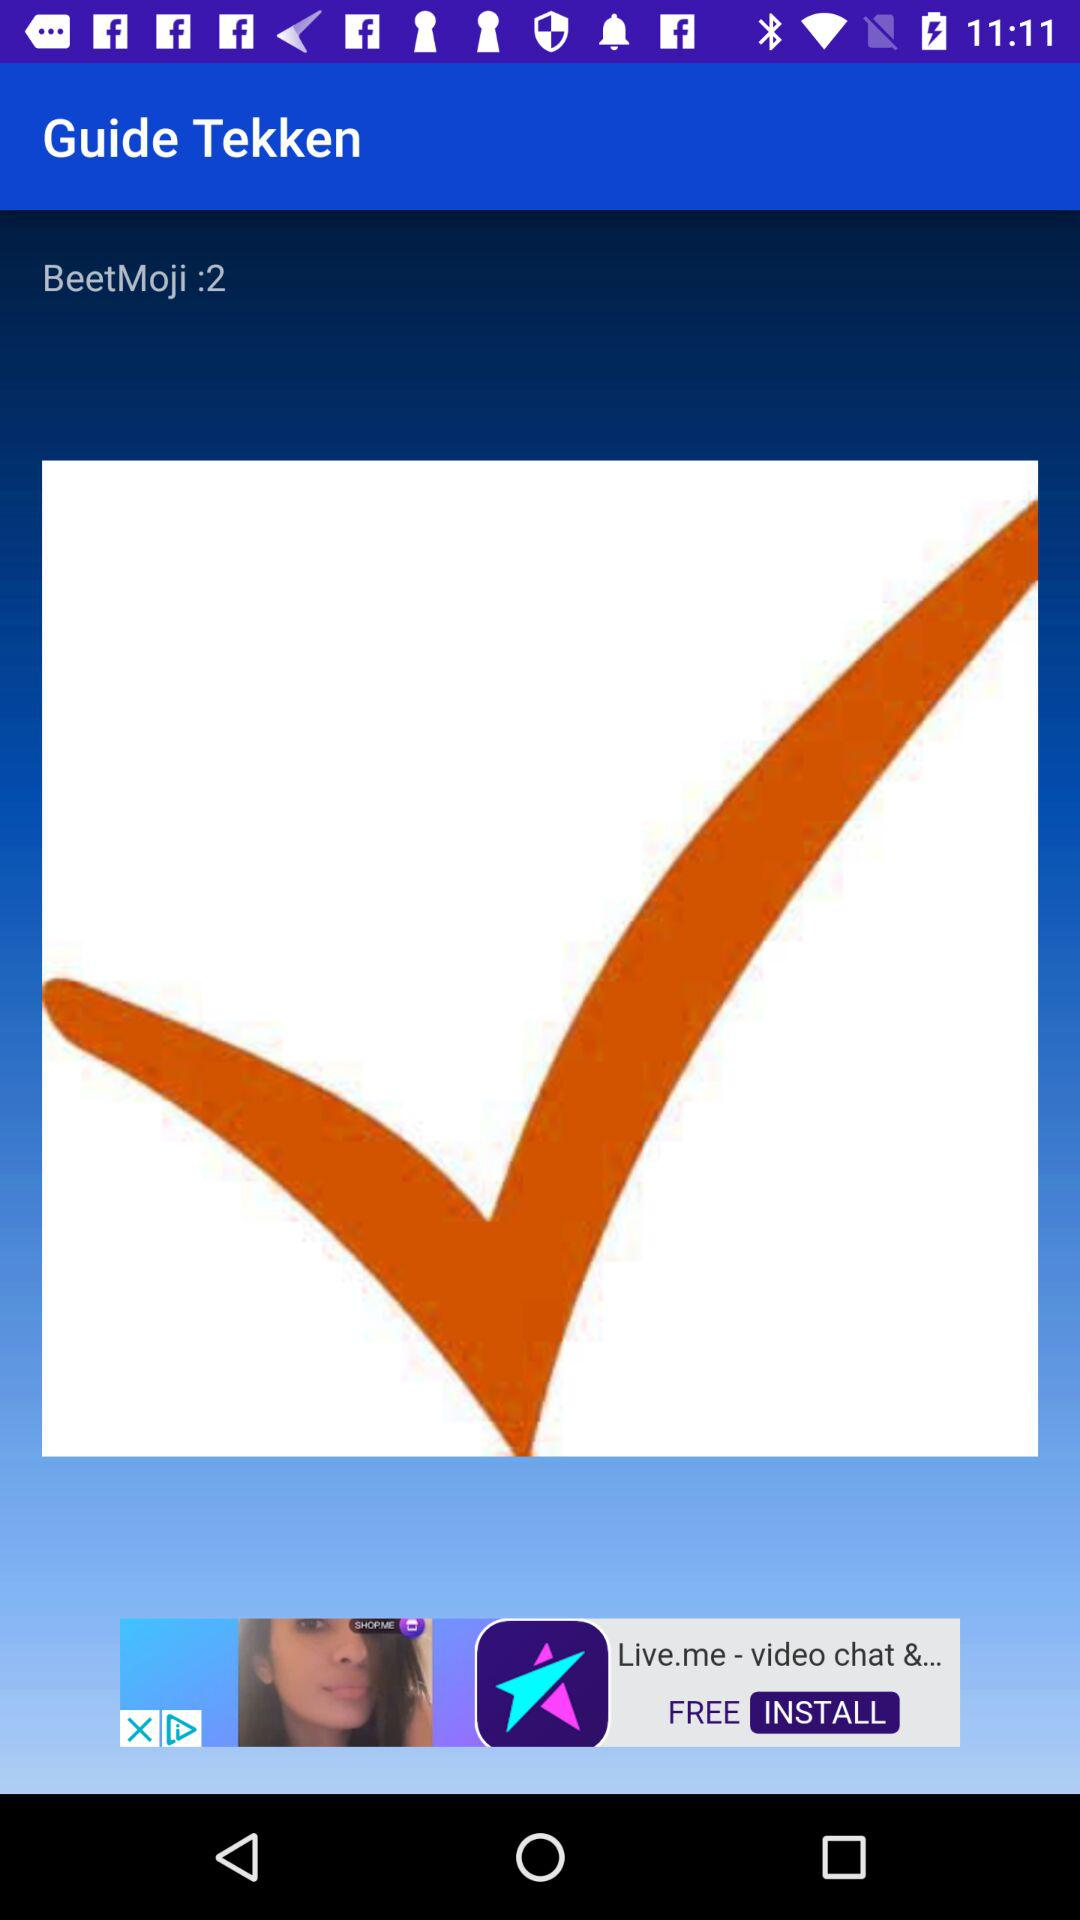What is the name of the application? The names of the applications are "Guide Tekken" and "BeetMoji :2". 